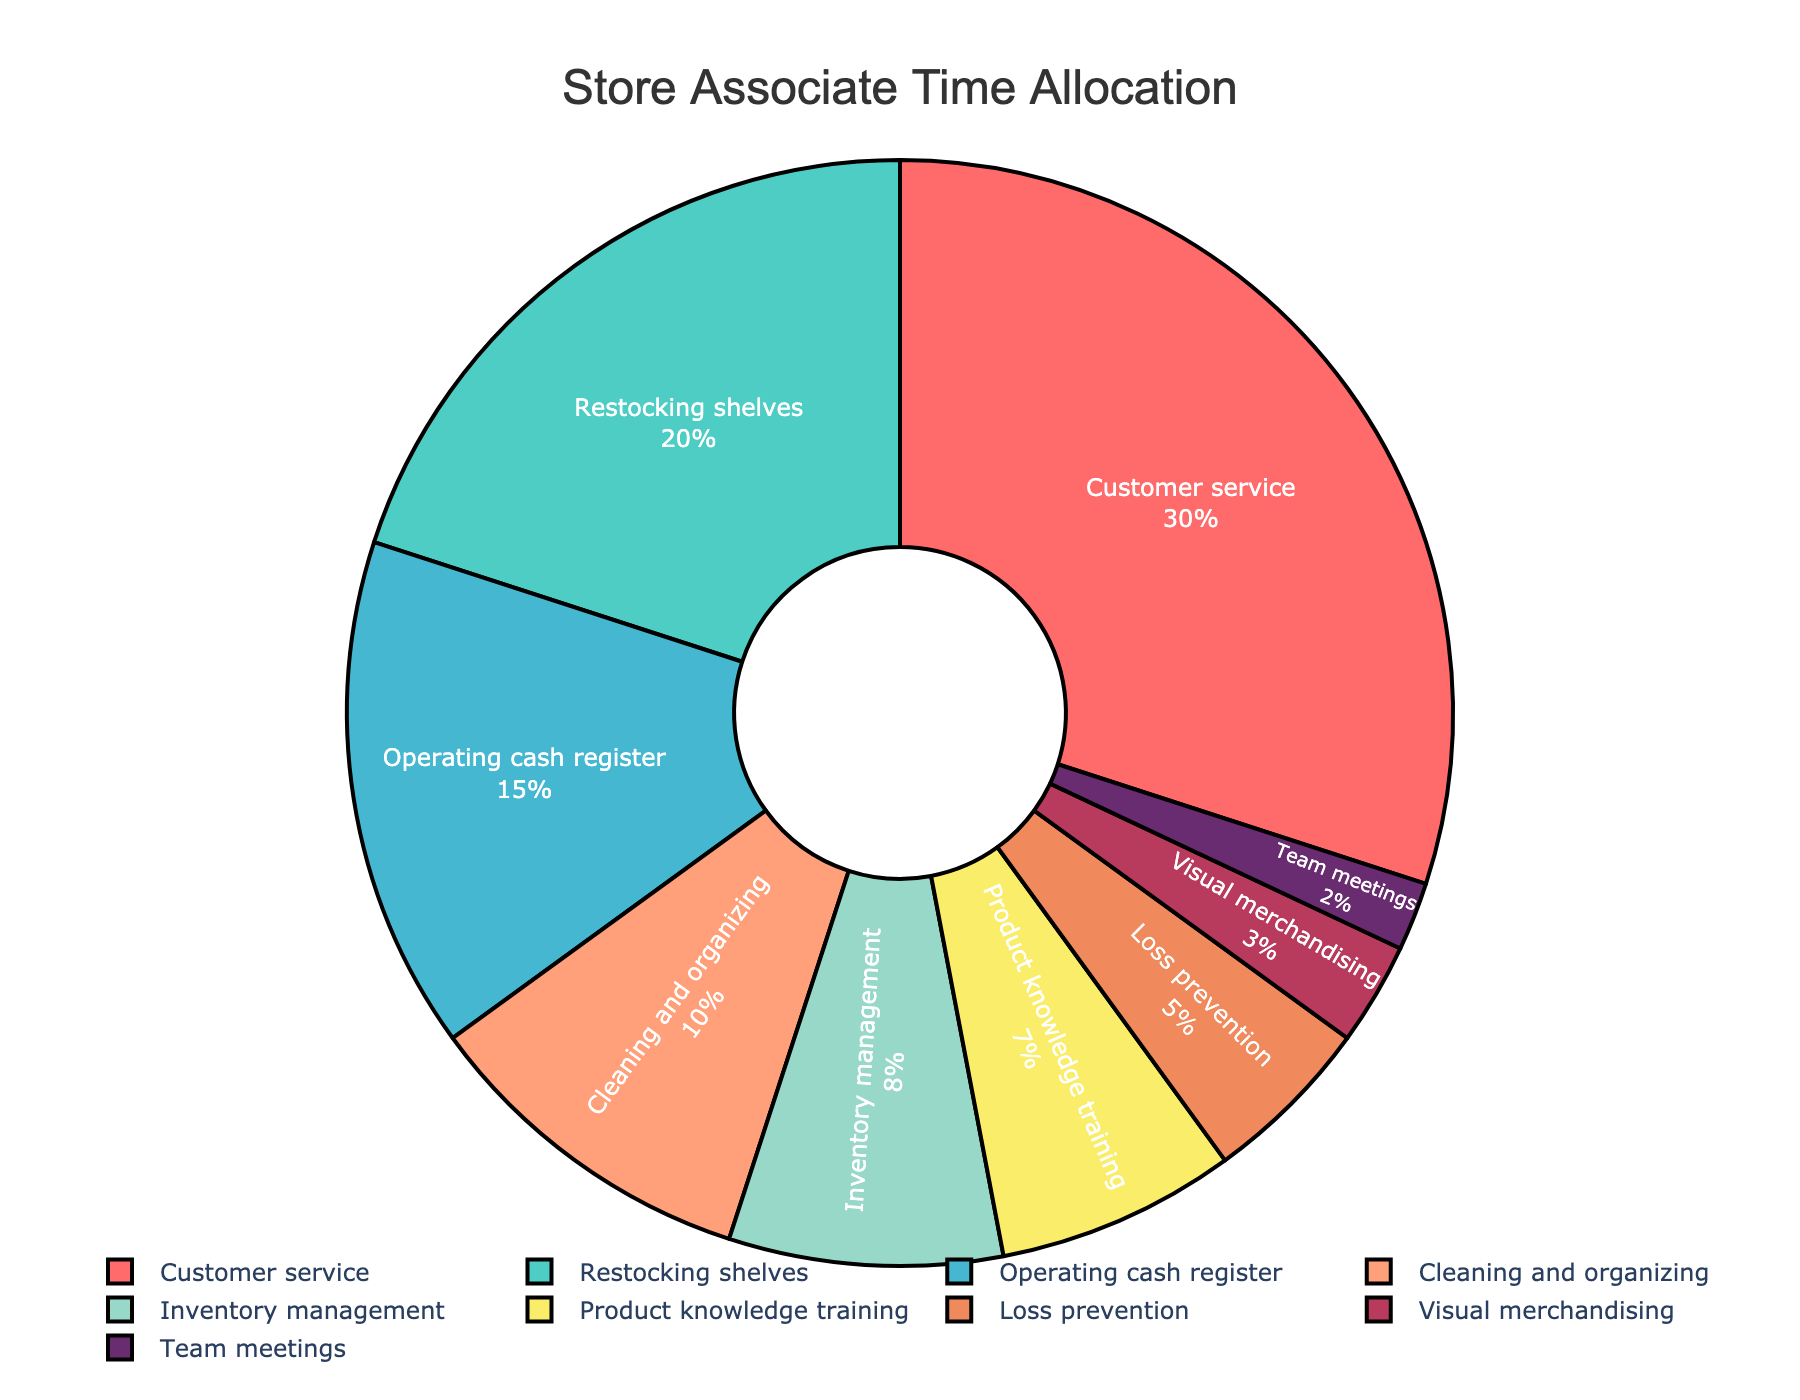What percentage of time is spent on customer service? The section of the pie chart labeled "Customer service" shows its percentage, which is 30%.
Answer: 30% How many tasks have a time allocation greater than 15%? Tasks with more than 15% allocation are "Customer service" (30%) and "Restocking shelves" (20%). This makes a total of 2 tasks.
Answer: 2 Which task has the lowest percentage of time allocated? The task with the smallest section in the pie chart is "Team meetings", with 2%.
Answer: Team meetings What is the combined percentage of time spent on restocking shelves and inventory management? Add the time allocated to "Restocking shelves" (20%) and "Inventory management" (8%). Summing them results in 28%.
Answer: 28% How does the time allocated to operating the cash register compare to cleaning and organizing? "Operating cash register" is allocated 15%, whereas "Cleaning and organizing" is 10%. Operating cash register has 5% more allocation than cleaning and organizing.
Answer: 5% more Which task is represented by the blue color in the pie chart? The blue section of the pie chart corresponds to "Operating cash register", which is 15%.
Answer: Operating cash register What is the total percentage of time spent on tasks related to customer interaction? "Customer service" (30%) and "Operating cash register" (15%) are the tasks related to customer interaction. Adding these gives 45%.
Answer: 45% What is the difference in time allocation between loss prevention and visual merchandising? "Loss prevention" has 5% and "Visual merchandising" has 3%, so the difference is 2%.
Answer: 2% What fraction of store associate time is spent on product knowledge training and team meetings combined? Product knowledge training (7%) + Team meetings (2%) = 9%. Hence, the fraction is 9%.
Answer: 9% How does the time spent on cleaning and organizing compare visually to other tasks? Its section is smaller than "Customer service" and "Restocking shelves", larger than "Loss prevention", "Visual merchandising", and "Team meetings", and about the same size as "Product knowledge training".
Answer: Smaller than some, larger than others, equal to some 